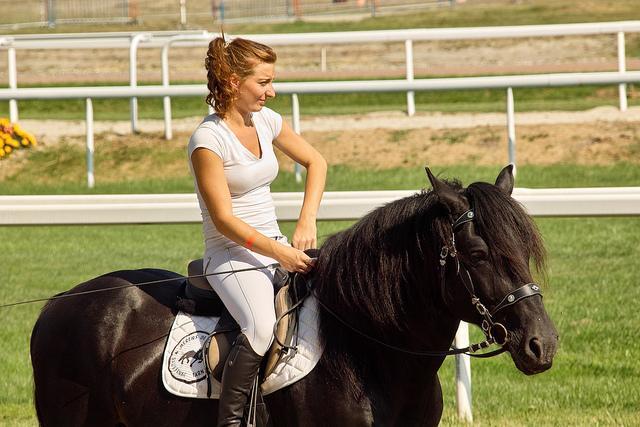How many black cows can be spotted in the background?
Give a very brief answer. 0. 